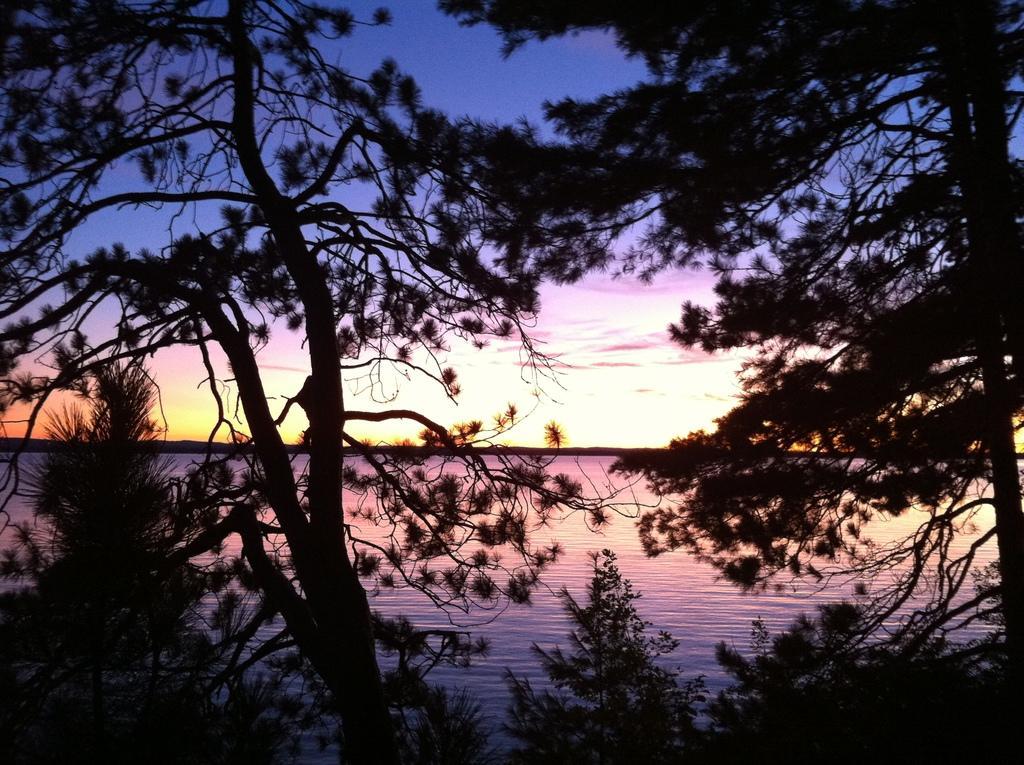Can you describe this image briefly? In this picture, we can see trees, water, and the sky with clouds. 